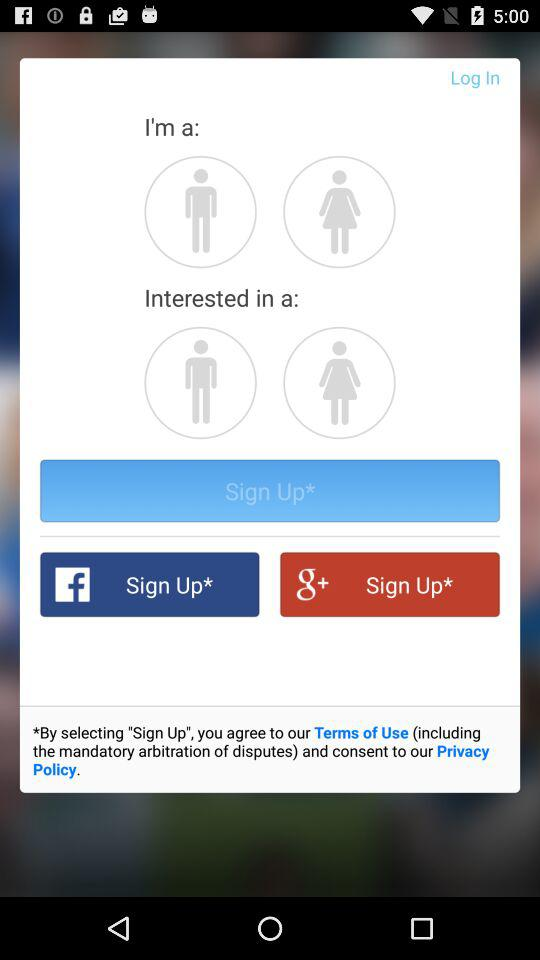What are the sign-up options? The sign-up options are "Facebook" and "Google+". 